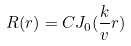<formula> <loc_0><loc_0><loc_500><loc_500>R ( r ) = C J _ { 0 } ( \frac { k } { v } r )</formula> 